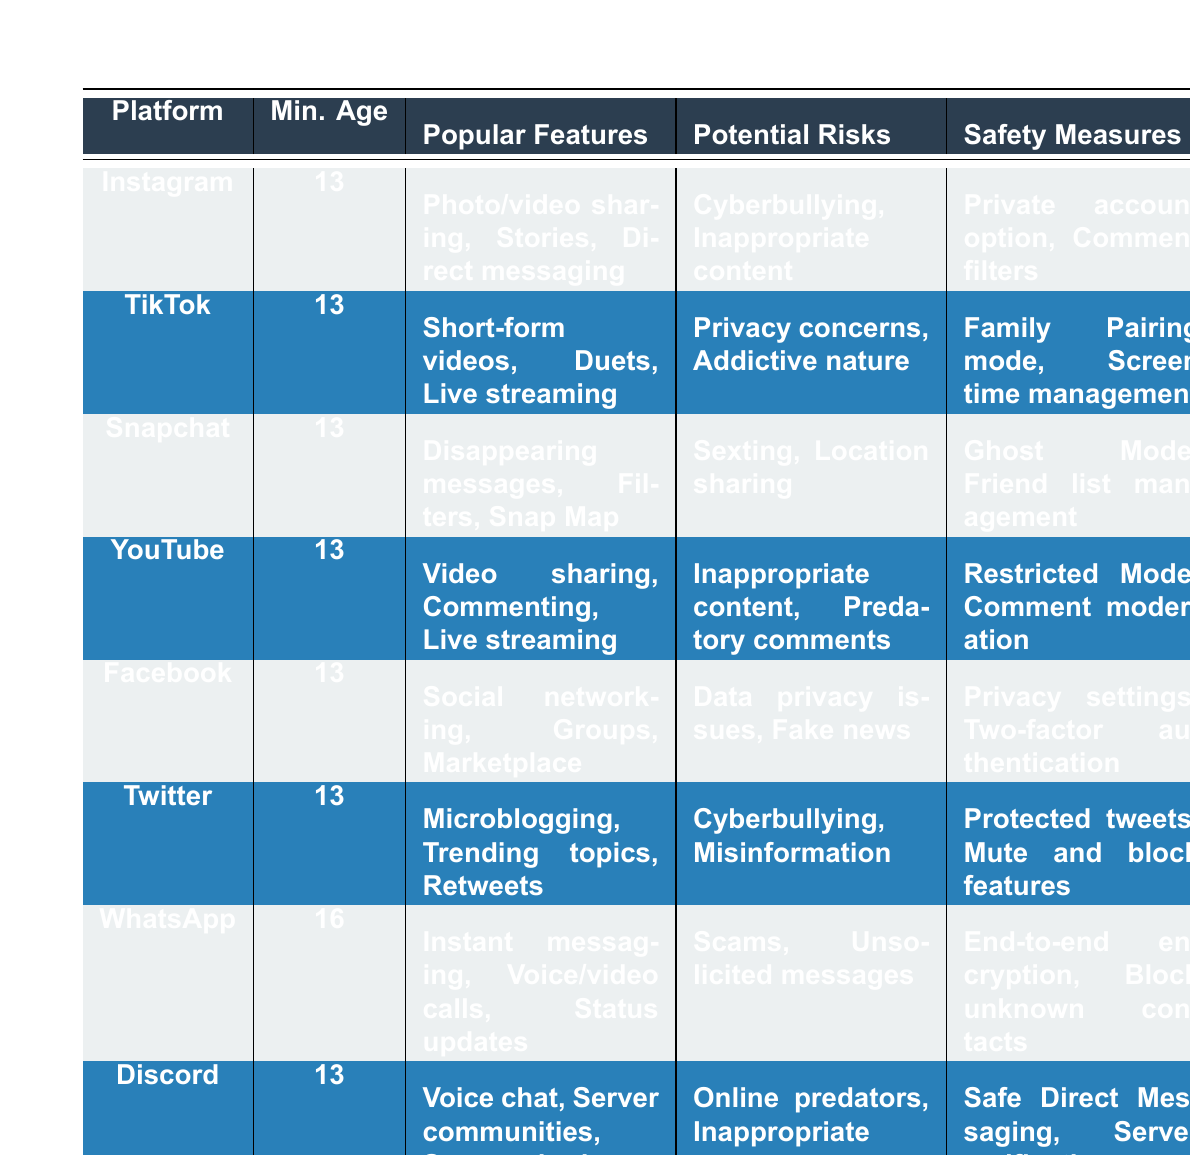What is the minimum age required to use Instagram? The table indicates that the minimum age for Instagram is listed in the "Minimum Age" column. Referring to the row for Instagram, it shows the minimum age as 13.
Answer: 13 Which social media platform has a minimum age of 16? Looking through the "Minimum Age" column, only WhatsApp has a listed minimum age of 16, while all other platforms have a minimum age of 13.
Answer: WhatsApp What are the popular features of TikTok? By checking the "Popular Features" column in the TikTok row, it is noted that the features include short-form videos, duets, and live streaming.
Answer: Short-form videos, Duets, Live streaming Is there a safety measure that protects against cyberbullying on Twitter? The "Safety Measures" column for Twitter indicates that protected tweets, as well as mute and block features, can help mitigate issues related to cyberbullying. Thus, these measures can be considered protective.
Answer: Yes Which platforms mention "location sharing" as a potential risk? Referring to the "Potential Risks" column, Snapchat clearly states "location sharing" whereas no other platform mentions this risk.
Answer: Snapchat How many platforms listed have a minimum age of 13, and which ones are they? Counting the platforms in the "Minimum Age" column, there are 7 platforms that have a minimum age of 13: Instagram, TikTok, Snapchat, YouTube, Facebook, Twitter, and Discord.
Answer: 7 platforms: Instagram, TikTok, Snapchat, YouTube, Facebook, Twitter, Discord What is the most common minimum age requirement for the platforms in this table? All platforms except WhatsApp have a minimum age of 13. This means the most common minimum age requirement is 13, as 7 out of 8 platforms have this age.
Answer: 13 Which platforms provide measures to manage screen time? Reviewing the "Safety Measures" for TikTok shows "Screen time management." This is the only platform listed in the table that provides this feature specifically related to managing screen time.
Answer: TikTok Are there any platforms that allow for private account settings? By inspecting the "Safety Measures" column, Instagram is the only platform that mentions a "Private account option" as a measure.
Answer: Yes, Instagram Which platform has the highest minimum age and what potential risk is associated with it? The platform with the highest minimum age is WhatsApp, which has a minimum age of 16. The "Potential Risks" identified for WhatsApp include scams and unsolicited messages.
Answer: WhatsApp; scams, unsolicited messages 